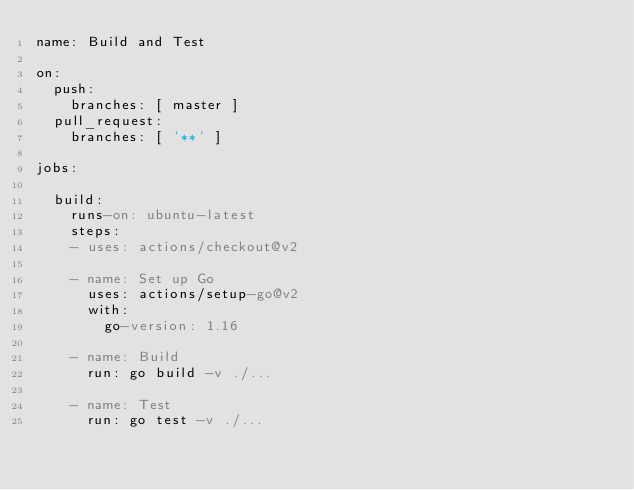<code> <loc_0><loc_0><loc_500><loc_500><_YAML_>name: Build and Test

on:
  push:
    branches: [ master ]
  pull_request:
    branches: [ '**' ]

jobs:

  build:
    runs-on: ubuntu-latest
    steps:
    - uses: actions/checkout@v2

    - name: Set up Go
      uses: actions/setup-go@v2
      with:
        go-version: 1.16

    - name: Build
      run: go build -v ./...

    - name: Test
      run: go test -v ./...
</code> 